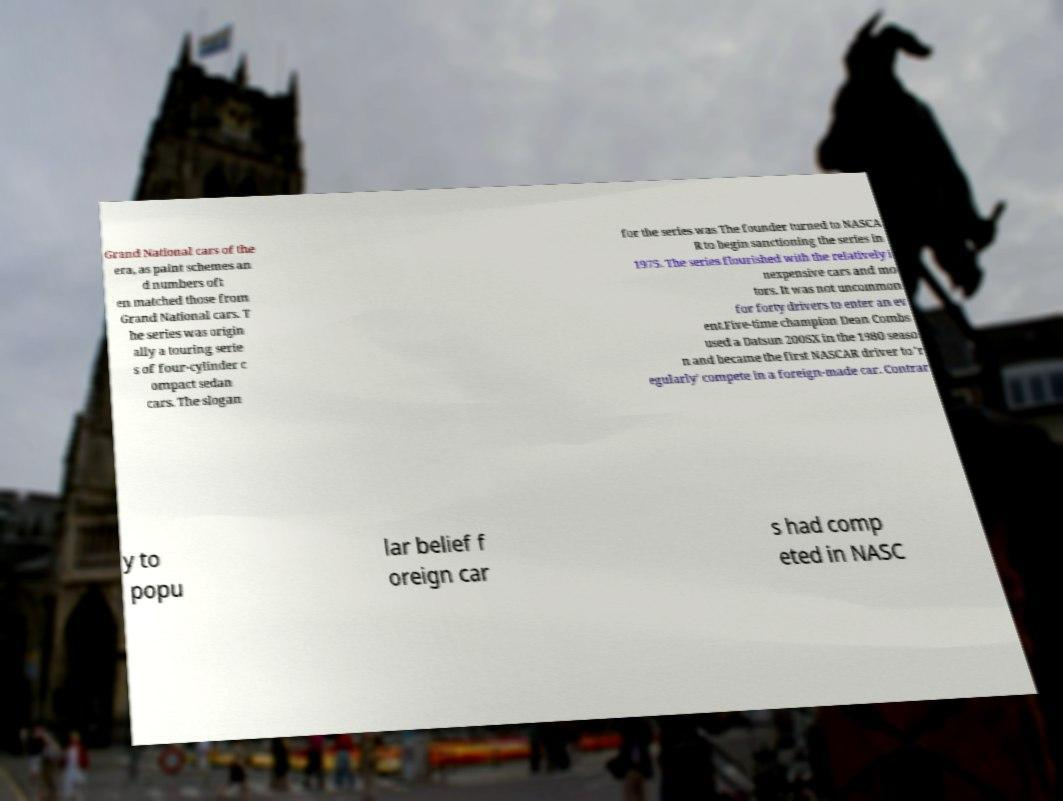For documentation purposes, I need the text within this image transcribed. Could you provide that? Grand National cars of the era, as paint schemes an d numbers oft en matched those from Grand National cars. T he series was origin ally a touring serie s of four-cylinder c ompact sedan cars. The slogan for the series was The founder turned to NASCA R to begin sanctioning the series in 1975. The series flourished with the relatively i nexpensive cars and mo tors. It was not uncommon for forty drivers to enter an ev ent.Five-time champion Dean Combs used a Datsun 200SX in the 1980 seaso n and became the first NASCAR driver to 'r egularly' compete in a foreign-made car. Contrar y to popu lar belief f oreign car s had comp eted in NASC 